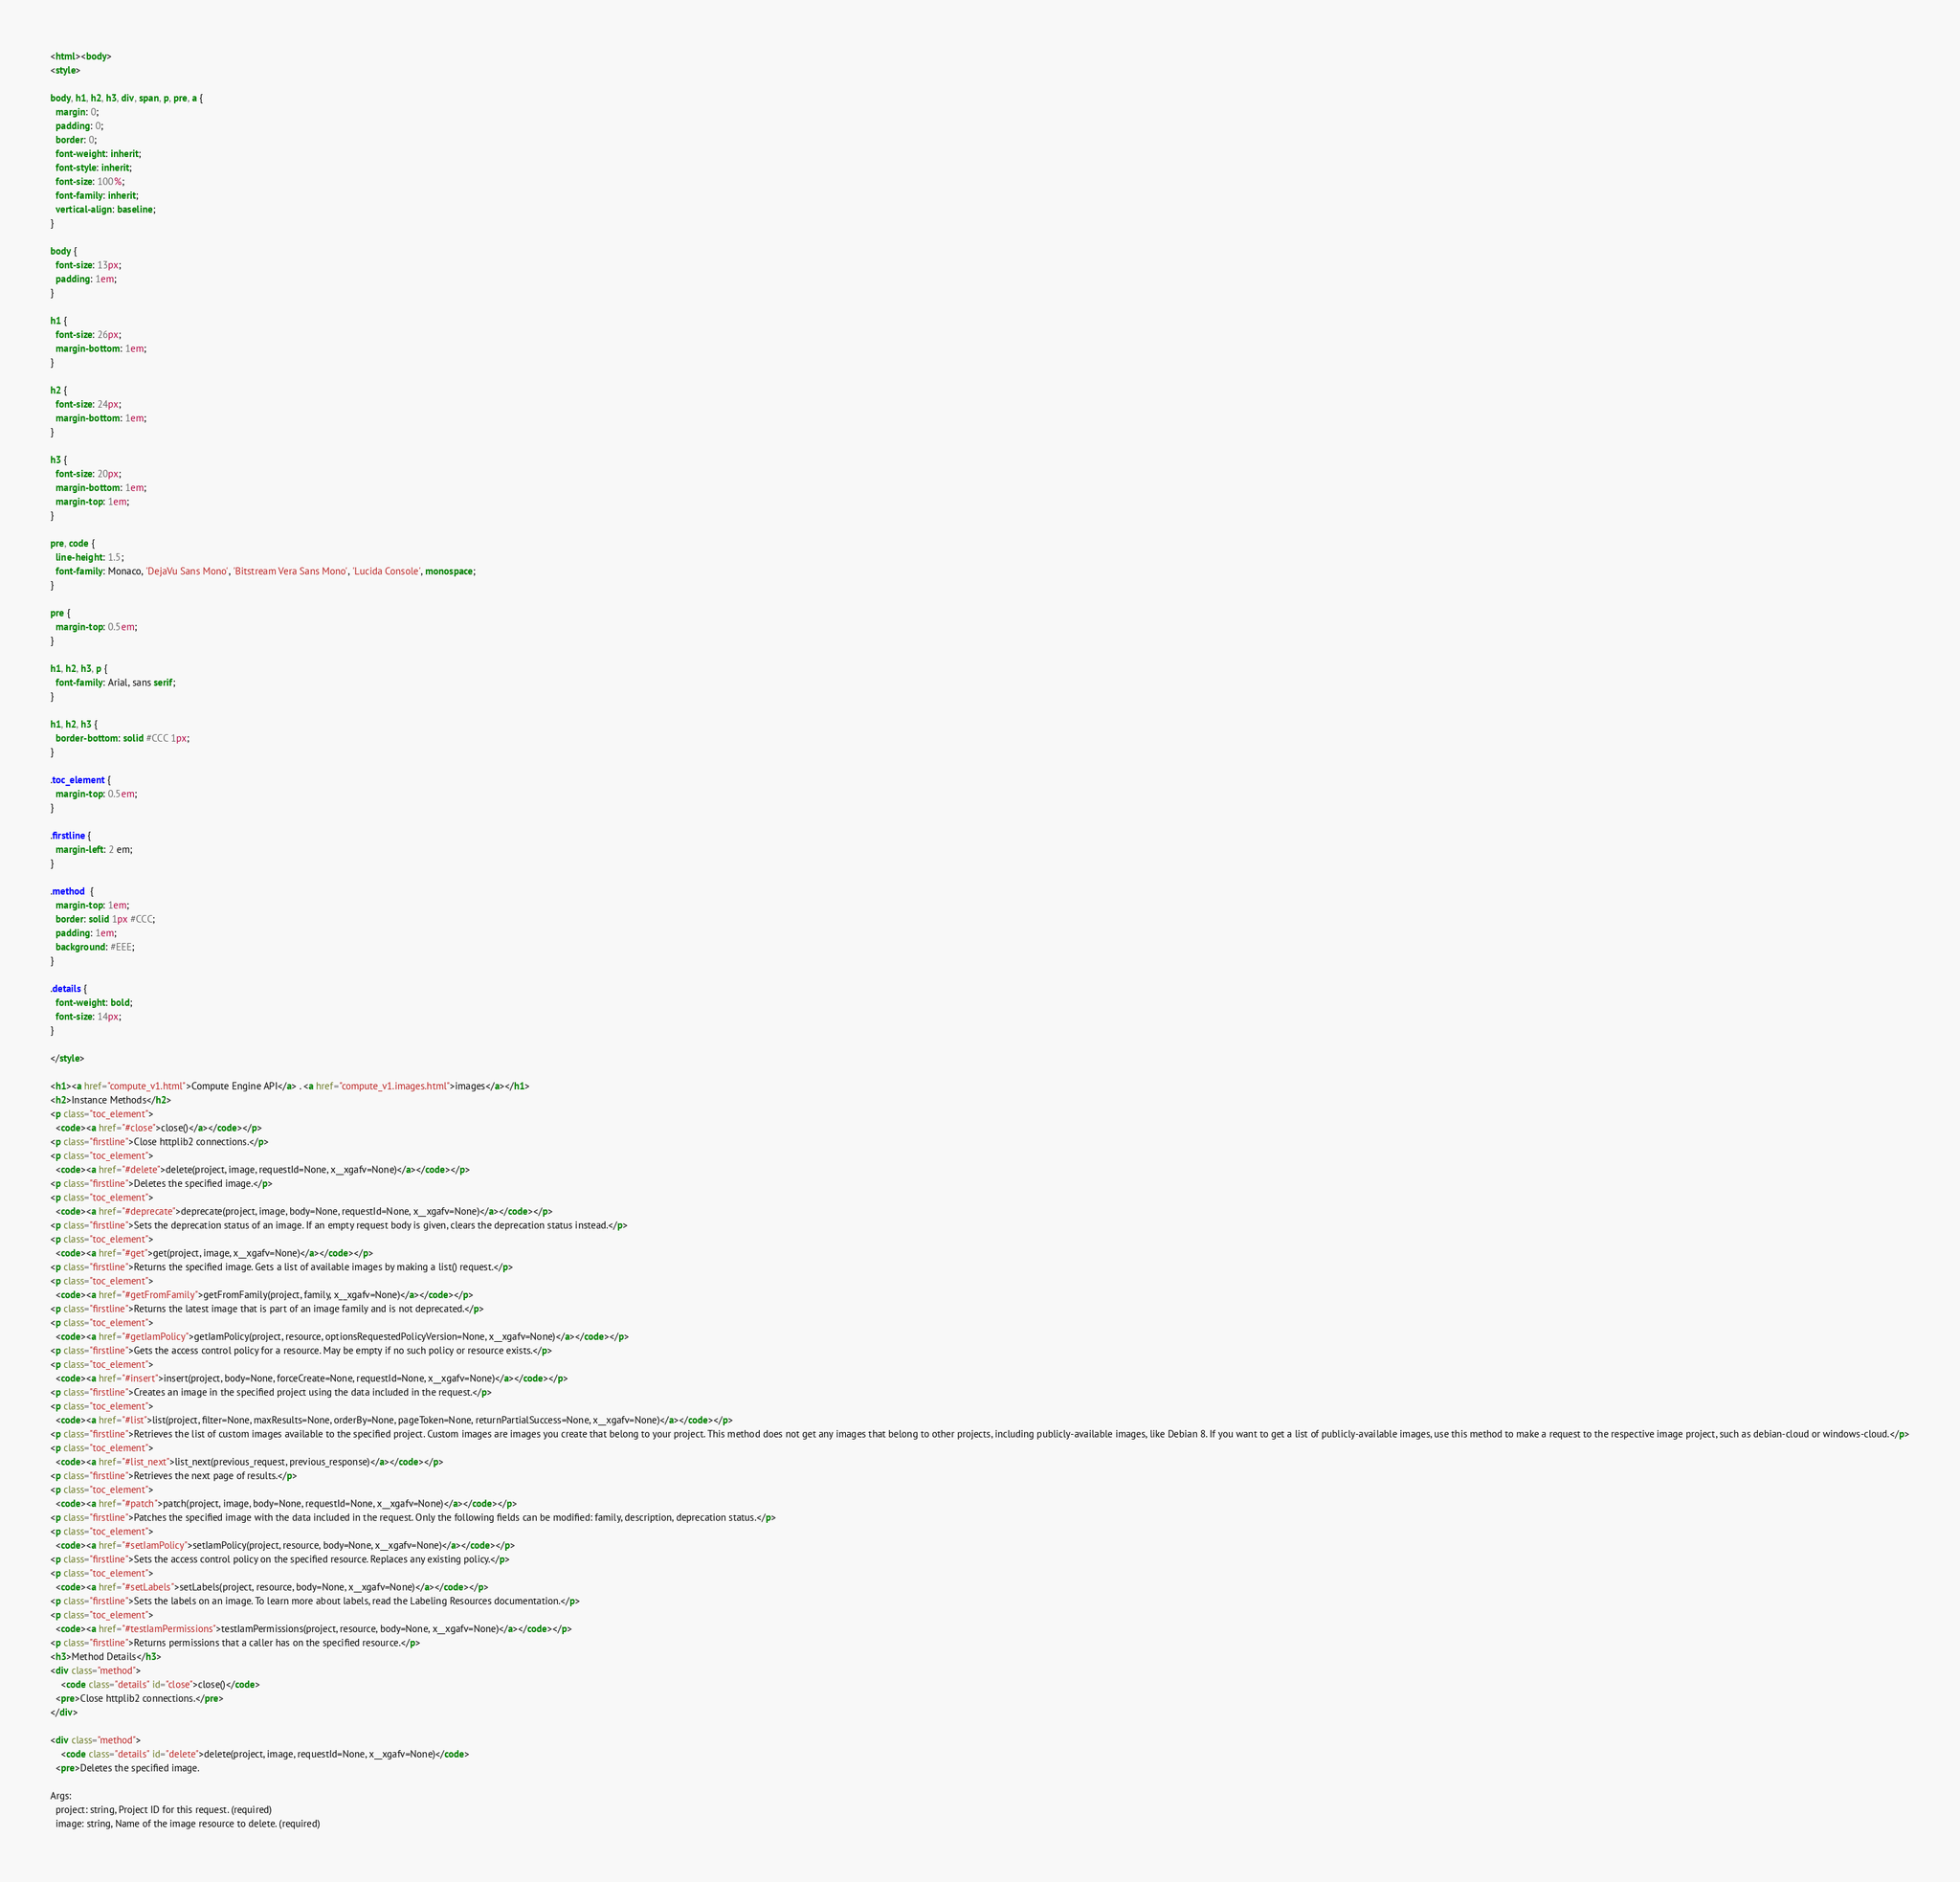Convert code to text. <code><loc_0><loc_0><loc_500><loc_500><_HTML_><html><body>
<style>

body, h1, h2, h3, div, span, p, pre, a {
  margin: 0;
  padding: 0;
  border: 0;
  font-weight: inherit;
  font-style: inherit;
  font-size: 100%;
  font-family: inherit;
  vertical-align: baseline;
}

body {
  font-size: 13px;
  padding: 1em;
}

h1 {
  font-size: 26px;
  margin-bottom: 1em;
}

h2 {
  font-size: 24px;
  margin-bottom: 1em;
}

h3 {
  font-size: 20px;
  margin-bottom: 1em;
  margin-top: 1em;
}

pre, code {
  line-height: 1.5;
  font-family: Monaco, 'DejaVu Sans Mono', 'Bitstream Vera Sans Mono', 'Lucida Console', monospace;
}

pre {
  margin-top: 0.5em;
}

h1, h2, h3, p {
  font-family: Arial, sans serif;
}

h1, h2, h3 {
  border-bottom: solid #CCC 1px;
}

.toc_element {
  margin-top: 0.5em;
}

.firstline {
  margin-left: 2 em;
}

.method  {
  margin-top: 1em;
  border: solid 1px #CCC;
  padding: 1em;
  background: #EEE;
}

.details {
  font-weight: bold;
  font-size: 14px;
}

</style>

<h1><a href="compute_v1.html">Compute Engine API</a> . <a href="compute_v1.images.html">images</a></h1>
<h2>Instance Methods</h2>
<p class="toc_element">
  <code><a href="#close">close()</a></code></p>
<p class="firstline">Close httplib2 connections.</p>
<p class="toc_element">
  <code><a href="#delete">delete(project, image, requestId=None, x__xgafv=None)</a></code></p>
<p class="firstline">Deletes the specified image.</p>
<p class="toc_element">
  <code><a href="#deprecate">deprecate(project, image, body=None, requestId=None, x__xgafv=None)</a></code></p>
<p class="firstline">Sets the deprecation status of an image. If an empty request body is given, clears the deprecation status instead.</p>
<p class="toc_element">
  <code><a href="#get">get(project, image, x__xgafv=None)</a></code></p>
<p class="firstline">Returns the specified image. Gets a list of available images by making a list() request.</p>
<p class="toc_element">
  <code><a href="#getFromFamily">getFromFamily(project, family, x__xgafv=None)</a></code></p>
<p class="firstline">Returns the latest image that is part of an image family and is not deprecated.</p>
<p class="toc_element">
  <code><a href="#getIamPolicy">getIamPolicy(project, resource, optionsRequestedPolicyVersion=None, x__xgafv=None)</a></code></p>
<p class="firstline">Gets the access control policy for a resource. May be empty if no such policy or resource exists.</p>
<p class="toc_element">
  <code><a href="#insert">insert(project, body=None, forceCreate=None, requestId=None, x__xgafv=None)</a></code></p>
<p class="firstline">Creates an image in the specified project using the data included in the request.</p>
<p class="toc_element">
  <code><a href="#list">list(project, filter=None, maxResults=None, orderBy=None, pageToken=None, returnPartialSuccess=None, x__xgafv=None)</a></code></p>
<p class="firstline">Retrieves the list of custom images available to the specified project. Custom images are images you create that belong to your project. This method does not get any images that belong to other projects, including publicly-available images, like Debian 8. If you want to get a list of publicly-available images, use this method to make a request to the respective image project, such as debian-cloud or windows-cloud.</p>
<p class="toc_element">
  <code><a href="#list_next">list_next(previous_request, previous_response)</a></code></p>
<p class="firstline">Retrieves the next page of results.</p>
<p class="toc_element">
  <code><a href="#patch">patch(project, image, body=None, requestId=None, x__xgafv=None)</a></code></p>
<p class="firstline">Patches the specified image with the data included in the request. Only the following fields can be modified: family, description, deprecation status.</p>
<p class="toc_element">
  <code><a href="#setIamPolicy">setIamPolicy(project, resource, body=None, x__xgafv=None)</a></code></p>
<p class="firstline">Sets the access control policy on the specified resource. Replaces any existing policy.</p>
<p class="toc_element">
  <code><a href="#setLabels">setLabels(project, resource, body=None, x__xgafv=None)</a></code></p>
<p class="firstline">Sets the labels on an image. To learn more about labels, read the Labeling Resources documentation.</p>
<p class="toc_element">
  <code><a href="#testIamPermissions">testIamPermissions(project, resource, body=None, x__xgafv=None)</a></code></p>
<p class="firstline">Returns permissions that a caller has on the specified resource.</p>
<h3>Method Details</h3>
<div class="method">
    <code class="details" id="close">close()</code>
  <pre>Close httplib2 connections.</pre>
</div>

<div class="method">
    <code class="details" id="delete">delete(project, image, requestId=None, x__xgafv=None)</code>
  <pre>Deletes the specified image.

Args:
  project: string, Project ID for this request. (required)
  image: string, Name of the image resource to delete. (required)</code> 